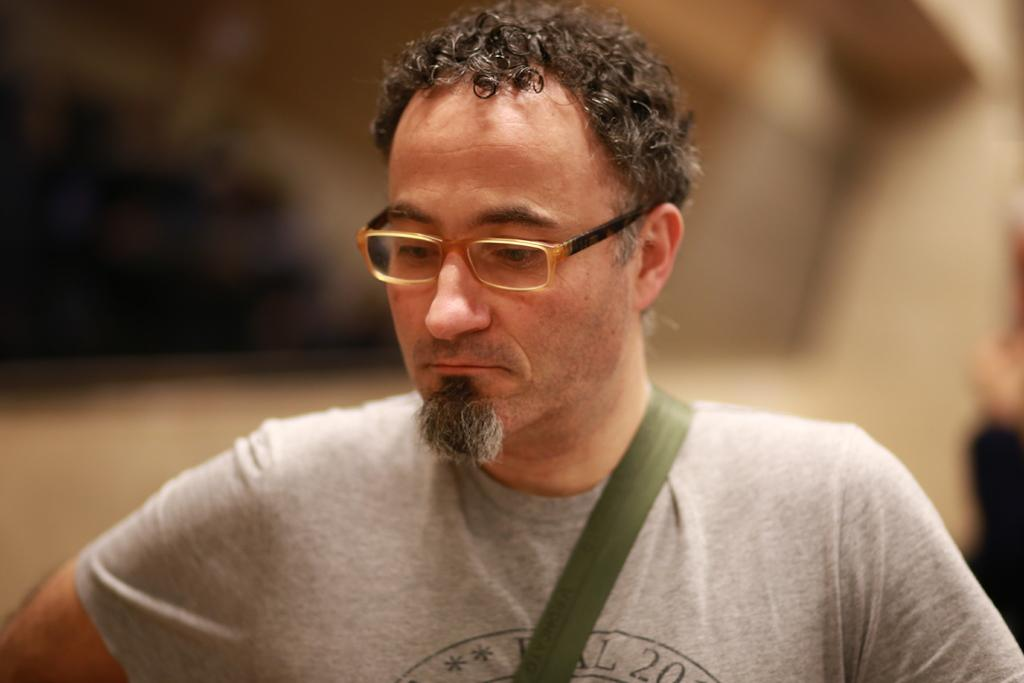Who is present in the image? There is a man in the image. What can be observed about the man's appearance? The man is wearing spectacles. Can you describe the background of the image? The background of the image is blurred. What type of potato is being used as a condition for the man's voyage in the image? There is no potato or voyage present in the image; it features a man wearing spectacles with a blurred background. 